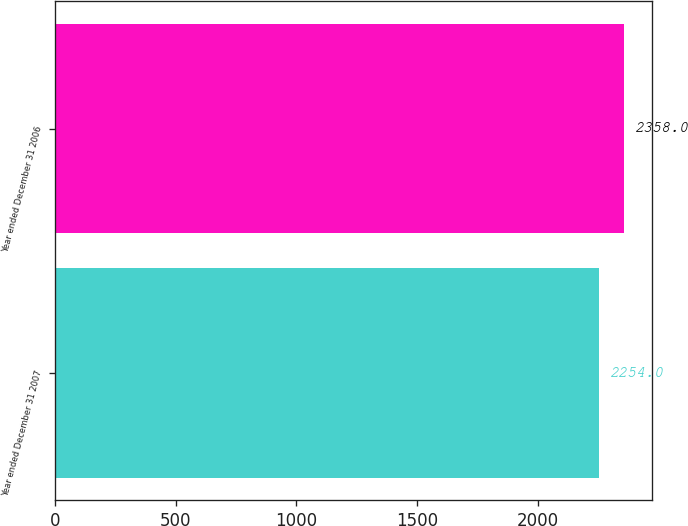Convert chart. <chart><loc_0><loc_0><loc_500><loc_500><bar_chart><fcel>Year ended December 31 2007<fcel>Year ended December 31 2006<nl><fcel>2254<fcel>2358<nl></chart> 